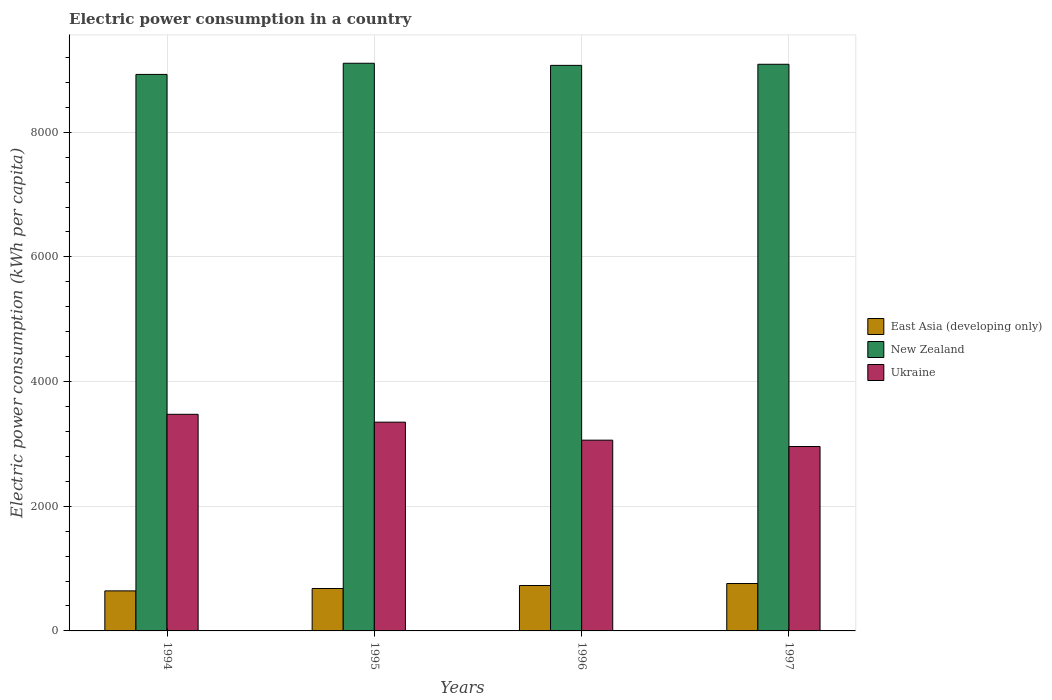How many different coloured bars are there?
Give a very brief answer. 3. How many groups of bars are there?
Provide a succinct answer. 4. Are the number of bars per tick equal to the number of legend labels?
Keep it short and to the point. Yes. Are the number of bars on each tick of the X-axis equal?
Offer a very short reply. Yes. How many bars are there on the 2nd tick from the left?
Provide a succinct answer. 3. How many bars are there on the 4th tick from the right?
Offer a very short reply. 3. What is the label of the 4th group of bars from the left?
Ensure brevity in your answer.  1997. What is the electric power consumption in in New Zealand in 1994?
Provide a short and direct response. 8927.9. Across all years, what is the maximum electric power consumption in in New Zealand?
Your response must be concise. 9106.82. Across all years, what is the minimum electric power consumption in in New Zealand?
Make the answer very short. 8927.9. In which year was the electric power consumption in in East Asia (developing only) maximum?
Your answer should be very brief. 1997. What is the total electric power consumption in in New Zealand in the graph?
Make the answer very short. 3.62e+04. What is the difference between the electric power consumption in in Ukraine in 1994 and that in 1996?
Your answer should be compact. 414.79. What is the difference between the electric power consumption in in New Zealand in 1994 and the electric power consumption in in Ukraine in 1995?
Offer a terse response. 5578.97. What is the average electric power consumption in in East Asia (developing only) per year?
Provide a succinct answer. 703.03. In the year 1997, what is the difference between the electric power consumption in in New Zealand and electric power consumption in in Ukraine?
Your answer should be very brief. 6131.94. In how many years, is the electric power consumption in in New Zealand greater than 6800 kWh per capita?
Provide a succinct answer. 4. What is the ratio of the electric power consumption in in New Zealand in 1994 to that in 1997?
Make the answer very short. 0.98. Is the electric power consumption in in Ukraine in 1996 less than that in 1997?
Offer a very short reply. No. Is the difference between the electric power consumption in in New Zealand in 1996 and 1997 greater than the difference between the electric power consumption in in Ukraine in 1996 and 1997?
Ensure brevity in your answer.  No. What is the difference between the highest and the second highest electric power consumption in in New Zealand?
Make the answer very short. 16.3. What is the difference between the highest and the lowest electric power consumption in in East Asia (developing only)?
Your answer should be compact. 118.11. In how many years, is the electric power consumption in in Ukraine greater than the average electric power consumption in in Ukraine taken over all years?
Provide a succinct answer. 2. Is the sum of the electric power consumption in in Ukraine in 1995 and 1996 greater than the maximum electric power consumption in in East Asia (developing only) across all years?
Provide a short and direct response. Yes. What does the 3rd bar from the left in 1996 represents?
Make the answer very short. Ukraine. What does the 1st bar from the right in 1997 represents?
Make the answer very short. Ukraine. Is it the case that in every year, the sum of the electric power consumption in in New Zealand and electric power consumption in in Ukraine is greater than the electric power consumption in in East Asia (developing only)?
Provide a succinct answer. Yes. How many bars are there?
Your answer should be very brief. 12. Does the graph contain any zero values?
Give a very brief answer. No. Does the graph contain grids?
Provide a short and direct response. Yes. Where does the legend appear in the graph?
Keep it short and to the point. Center right. How many legend labels are there?
Your answer should be very brief. 3. What is the title of the graph?
Provide a succinct answer. Electric power consumption in a country. What is the label or title of the Y-axis?
Keep it short and to the point. Electric power consumption (kWh per capita). What is the Electric power consumption (kWh per capita) in East Asia (developing only) in 1994?
Provide a short and direct response. 642.38. What is the Electric power consumption (kWh per capita) in New Zealand in 1994?
Your answer should be very brief. 8927.9. What is the Electric power consumption (kWh per capita) in Ukraine in 1994?
Provide a succinct answer. 3475.16. What is the Electric power consumption (kWh per capita) in East Asia (developing only) in 1995?
Provide a succinct answer. 680.76. What is the Electric power consumption (kWh per capita) of New Zealand in 1995?
Provide a short and direct response. 9106.82. What is the Electric power consumption (kWh per capita) of Ukraine in 1995?
Ensure brevity in your answer.  3348.93. What is the Electric power consumption (kWh per capita) of East Asia (developing only) in 1996?
Provide a short and direct response. 728.48. What is the Electric power consumption (kWh per capita) of New Zealand in 1996?
Your answer should be compact. 9072.88. What is the Electric power consumption (kWh per capita) of Ukraine in 1996?
Make the answer very short. 3060.37. What is the Electric power consumption (kWh per capita) of East Asia (developing only) in 1997?
Your answer should be very brief. 760.49. What is the Electric power consumption (kWh per capita) of New Zealand in 1997?
Make the answer very short. 9090.52. What is the Electric power consumption (kWh per capita) in Ukraine in 1997?
Your answer should be compact. 2958.59. Across all years, what is the maximum Electric power consumption (kWh per capita) of East Asia (developing only)?
Make the answer very short. 760.49. Across all years, what is the maximum Electric power consumption (kWh per capita) of New Zealand?
Your answer should be compact. 9106.82. Across all years, what is the maximum Electric power consumption (kWh per capita) of Ukraine?
Offer a terse response. 3475.16. Across all years, what is the minimum Electric power consumption (kWh per capita) in East Asia (developing only)?
Offer a terse response. 642.38. Across all years, what is the minimum Electric power consumption (kWh per capita) of New Zealand?
Your response must be concise. 8927.9. Across all years, what is the minimum Electric power consumption (kWh per capita) in Ukraine?
Your response must be concise. 2958.59. What is the total Electric power consumption (kWh per capita) in East Asia (developing only) in the graph?
Offer a very short reply. 2812.12. What is the total Electric power consumption (kWh per capita) in New Zealand in the graph?
Your answer should be compact. 3.62e+04. What is the total Electric power consumption (kWh per capita) in Ukraine in the graph?
Provide a succinct answer. 1.28e+04. What is the difference between the Electric power consumption (kWh per capita) of East Asia (developing only) in 1994 and that in 1995?
Ensure brevity in your answer.  -38.38. What is the difference between the Electric power consumption (kWh per capita) in New Zealand in 1994 and that in 1995?
Ensure brevity in your answer.  -178.92. What is the difference between the Electric power consumption (kWh per capita) of Ukraine in 1994 and that in 1995?
Provide a succinct answer. 126.23. What is the difference between the Electric power consumption (kWh per capita) in East Asia (developing only) in 1994 and that in 1996?
Keep it short and to the point. -86.1. What is the difference between the Electric power consumption (kWh per capita) of New Zealand in 1994 and that in 1996?
Make the answer very short. -144.98. What is the difference between the Electric power consumption (kWh per capita) in Ukraine in 1994 and that in 1996?
Offer a very short reply. 414.79. What is the difference between the Electric power consumption (kWh per capita) in East Asia (developing only) in 1994 and that in 1997?
Offer a very short reply. -118.11. What is the difference between the Electric power consumption (kWh per capita) in New Zealand in 1994 and that in 1997?
Offer a terse response. -162.62. What is the difference between the Electric power consumption (kWh per capita) in Ukraine in 1994 and that in 1997?
Your response must be concise. 516.58. What is the difference between the Electric power consumption (kWh per capita) in East Asia (developing only) in 1995 and that in 1996?
Give a very brief answer. -47.72. What is the difference between the Electric power consumption (kWh per capita) of New Zealand in 1995 and that in 1996?
Provide a short and direct response. 33.94. What is the difference between the Electric power consumption (kWh per capita) in Ukraine in 1995 and that in 1996?
Offer a terse response. 288.56. What is the difference between the Electric power consumption (kWh per capita) in East Asia (developing only) in 1995 and that in 1997?
Offer a very short reply. -79.73. What is the difference between the Electric power consumption (kWh per capita) in New Zealand in 1995 and that in 1997?
Your answer should be very brief. 16.3. What is the difference between the Electric power consumption (kWh per capita) in Ukraine in 1995 and that in 1997?
Provide a short and direct response. 390.34. What is the difference between the Electric power consumption (kWh per capita) of East Asia (developing only) in 1996 and that in 1997?
Offer a very short reply. -32.01. What is the difference between the Electric power consumption (kWh per capita) of New Zealand in 1996 and that in 1997?
Make the answer very short. -17.64. What is the difference between the Electric power consumption (kWh per capita) in Ukraine in 1996 and that in 1997?
Provide a succinct answer. 101.79. What is the difference between the Electric power consumption (kWh per capita) in East Asia (developing only) in 1994 and the Electric power consumption (kWh per capita) in New Zealand in 1995?
Provide a succinct answer. -8464.44. What is the difference between the Electric power consumption (kWh per capita) in East Asia (developing only) in 1994 and the Electric power consumption (kWh per capita) in Ukraine in 1995?
Make the answer very short. -2706.55. What is the difference between the Electric power consumption (kWh per capita) in New Zealand in 1994 and the Electric power consumption (kWh per capita) in Ukraine in 1995?
Your response must be concise. 5578.97. What is the difference between the Electric power consumption (kWh per capita) of East Asia (developing only) in 1994 and the Electric power consumption (kWh per capita) of New Zealand in 1996?
Provide a short and direct response. -8430.5. What is the difference between the Electric power consumption (kWh per capita) in East Asia (developing only) in 1994 and the Electric power consumption (kWh per capita) in Ukraine in 1996?
Provide a short and direct response. -2417.99. What is the difference between the Electric power consumption (kWh per capita) in New Zealand in 1994 and the Electric power consumption (kWh per capita) in Ukraine in 1996?
Offer a very short reply. 5867.53. What is the difference between the Electric power consumption (kWh per capita) of East Asia (developing only) in 1994 and the Electric power consumption (kWh per capita) of New Zealand in 1997?
Your answer should be compact. -8448.14. What is the difference between the Electric power consumption (kWh per capita) of East Asia (developing only) in 1994 and the Electric power consumption (kWh per capita) of Ukraine in 1997?
Make the answer very short. -2316.21. What is the difference between the Electric power consumption (kWh per capita) in New Zealand in 1994 and the Electric power consumption (kWh per capita) in Ukraine in 1997?
Keep it short and to the point. 5969.31. What is the difference between the Electric power consumption (kWh per capita) of East Asia (developing only) in 1995 and the Electric power consumption (kWh per capita) of New Zealand in 1996?
Keep it short and to the point. -8392.12. What is the difference between the Electric power consumption (kWh per capita) of East Asia (developing only) in 1995 and the Electric power consumption (kWh per capita) of Ukraine in 1996?
Your answer should be very brief. -2379.61. What is the difference between the Electric power consumption (kWh per capita) of New Zealand in 1995 and the Electric power consumption (kWh per capita) of Ukraine in 1996?
Your answer should be very brief. 6046.45. What is the difference between the Electric power consumption (kWh per capita) in East Asia (developing only) in 1995 and the Electric power consumption (kWh per capita) in New Zealand in 1997?
Your answer should be very brief. -8409.76. What is the difference between the Electric power consumption (kWh per capita) in East Asia (developing only) in 1995 and the Electric power consumption (kWh per capita) in Ukraine in 1997?
Keep it short and to the point. -2277.82. What is the difference between the Electric power consumption (kWh per capita) in New Zealand in 1995 and the Electric power consumption (kWh per capita) in Ukraine in 1997?
Make the answer very short. 6148.24. What is the difference between the Electric power consumption (kWh per capita) in East Asia (developing only) in 1996 and the Electric power consumption (kWh per capita) in New Zealand in 1997?
Your response must be concise. -8362.04. What is the difference between the Electric power consumption (kWh per capita) of East Asia (developing only) in 1996 and the Electric power consumption (kWh per capita) of Ukraine in 1997?
Your response must be concise. -2230.1. What is the difference between the Electric power consumption (kWh per capita) in New Zealand in 1996 and the Electric power consumption (kWh per capita) in Ukraine in 1997?
Ensure brevity in your answer.  6114.3. What is the average Electric power consumption (kWh per capita) in East Asia (developing only) per year?
Provide a short and direct response. 703.03. What is the average Electric power consumption (kWh per capita) in New Zealand per year?
Offer a terse response. 9049.53. What is the average Electric power consumption (kWh per capita) of Ukraine per year?
Your response must be concise. 3210.76. In the year 1994, what is the difference between the Electric power consumption (kWh per capita) of East Asia (developing only) and Electric power consumption (kWh per capita) of New Zealand?
Your answer should be very brief. -8285.52. In the year 1994, what is the difference between the Electric power consumption (kWh per capita) of East Asia (developing only) and Electric power consumption (kWh per capita) of Ukraine?
Offer a very short reply. -2832.78. In the year 1994, what is the difference between the Electric power consumption (kWh per capita) of New Zealand and Electric power consumption (kWh per capita) of Ukraine?
Offer a terse response. 5452.74. In the year 1995, what is the difference between the Electric power consumption (kWh per capita) of East Asia (developing only) and Electric power consumption (kWh per capita) of New Zealand?
Provide a succinct answer. -8426.06. In the year 1995, what is the difference between the Electric power consumption (kWh per capita) in East Asia (developing only) and Electric power consumption (kWh per capita) in Ukraine?
Your answer should be compact. -2668.17. In the year 1995, what is the difference between the Electric power consumption (kWh per capita) of New Zealand and Electric power consumption (kWh per capita) of Ukraine?
Keep it short and to the point. 5757.89. In the year 1996, what is the difference between the Electric power consumption (kWh per capita) of East Asia (developing only) and Electric power consumption (kWh per capita) of New Zealand?
Your answer should be compact. -8344.4. In the year 1996, what is the difference between the Electric power consumption (kWh per capita) in East Asia (developing only) and Electric power consumption (kWh per capita) in Ukraine?
Offer a very short reply. -2331.89. In the year 1996, what is the difference between the Electric power consumption (kWh per capita) in New Zealand and Electric power consumption (kWh per capita) in Ukraine?
Offer a very short reply. 6012.51. In the year 1997, what is the difference between the Electric power consumption (kWh per capita) in East Asia (developing only) and Electric power consumption (kWh per capita) in New Zealand?
Keep it short and to the point. -8330.03. In the year 1997, what is the difference between the Electric power consumption (kWh per capita) of East Asia (developing only) and Electric power consumption (kWh per capita) of Ukraine?
Your answer should be very brief. -2198.09. In the year 1997, what is the difference between the Electric power consumption (kWh per capita) in New Zealand and Electric power consumption (kWh per capita) in Ukraine?
Provide a succinct answer. 6131.94. What is the ratio of the Electric power consumption (kWh per capita) in East Asia (developing only) in 1994 to that in 1995?
Provide a short and direct response. 0.94. What is the ratio of the Electric power consumption (kWh per capita) of New Zealand in 1994 to that in 1995?
Give a very brief answer. 0.98. What is the ratio of the Electric power consumption (kWh per capita) in Ukraine in 1994 to that in 1995?
Keep it short and to the point. 1.04. What is the ratio of the Electric power consumption (kWh per capita) of East Asia (developing only) in 1994 to that in 1996?
Keep it short and to the point. 0.88. What is the ratio of the Electric power consumption (kWh per capita) in Ukraine in 1994 to that in 1996?
Make the answer very short. 1.14. What is the ratio of the Electric power consumption (kWh per capita) in East Asia (developing only) in 1994 to that in 1997?
Give a very brief answer. 0.84. What is the ratio of the Electric power consumption (kWh per capita) in New Zealand in 1994 to that in 1997?
Your answer should be compact. 0.98. What is the ratio of the Electric power consumption (kWh per capita) in Ukraine in 1994 to that in 1997?
Provide a short and direct response. 1.17. What is the ratio of the Electric power consumption (kWh per capita) of East Asia (developing only) in 1995 to that in 1996?
Offer a very short reply. 0.93. What is the ratio of the Electric power consumption (kWh per capita) of New Zealand in 1995 to that in 1996?
Provide a succinct answer. 1. What is the ratio of the Electric power consumption (kWh per capita) in Ukraine in 1995 to that in 1996?
Your answer should be very brief. 1.09. What is the ratio of the Electric power consumption (kWh per capita) of East Asia (developing only) in 1995 to that in 1997?
Offer a terse response. 0.9. What is the ratio of the Electric power consumption (kWh per capita) of Ukraine in 1995 to that in 1997?
Your answer should be compact. 1.13. What is the ratio of the Electric power consumption (kWh per capita) in East Asia (developing only) in 1996 to that in 1997?
Offer a very short reply. 0.96. What is the ratio of the Electric power consumption (kWh per capita) of New Zealand in 1996 to that in 1997?
Your response must be concise. 1. What is the ratio of the Electric power consumption (kWh per capita) of Ukraine in 1996 to that in 1997?
Your response must be concise. 1.03. What is the difference between the highest and the second highest Electric power consumption (kWh per capita) in East Asia (developing only)?
Offer a very short reply. 32.01. What is the difference between the highest and the second highest Electric power consumption (kWh per capita) of New Zealand?
Ensure brevity in your answer.  16.3. What is the difference between the highest and the second highest Electric power consumption (kWh per capita) of Ukraine?
Offer a terse response. 126.23. What is the difference between the highest and the lowest Electric power consumption (kWh per capita) of East Asia (developing only)?
Offer a terse response. 118.11. What is the difference between the highest and the lowest Electric power consumption (kWh per capita) of New Zealand?
Offer a very short reply. 178.92. What is the difference between the highest and the lowest Electric power consumption (kWh per capita) of Ukraine?
Provide a succinct answer. 516.58. 